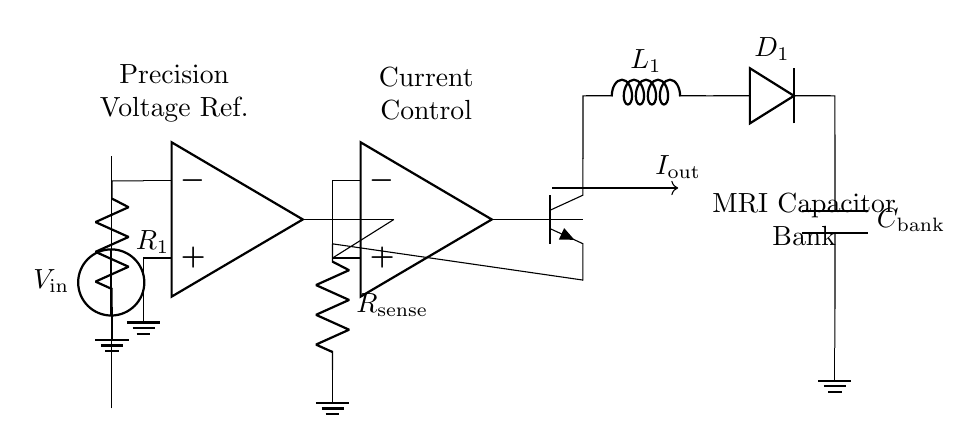What is the input voltage of the circuit? The input voltage is indicated as V in on the circuit schematic, which is the source supplying power to the configuration.
Answer: V in What component is used for current sensing? The sensing of current is achieved through the resistor labeled R sense. This is placed in series with the output path to measure the current flowing through it.
Answer: R sense What type of devices are used for current control in this circuit? The circuit utilizes operational amplifiers, specifically indicated by op amp labels, to manage the current flow through feedback mechanisms.
Answer: Operational amplifiers What is the purpose of the voltage reference in the circuit? The precision voltage reference serves to establish a stable voltage level against which the current can be controlled and regulated, ensuring the desired output current flow.
Answer: Stable voltage level How is the output current directed in the circuit? The output current I out is directed from the collector of the npn transistor which switches the current flow into the capacitor bank. The layout indicates the path for current to flow out of the circuit.
Answer: Through the npn transistor What happens to the current when the capacitor bank is fully charged? When the capacitor bank reaches its full charge, the feedback system regulates the operational amplifiers to minimize or stop the output current, effectively balancing the circuit and preventing overcharging.
Answer: Output current decreases What is the role of the diode in this circuit? The diode D 1 is used to ensure current flows in a specific direction towards the capacitor bank and prevents reverse current that could potentially damage the components or disrupt the charging process.
Answer: Ensure one-way current flow 